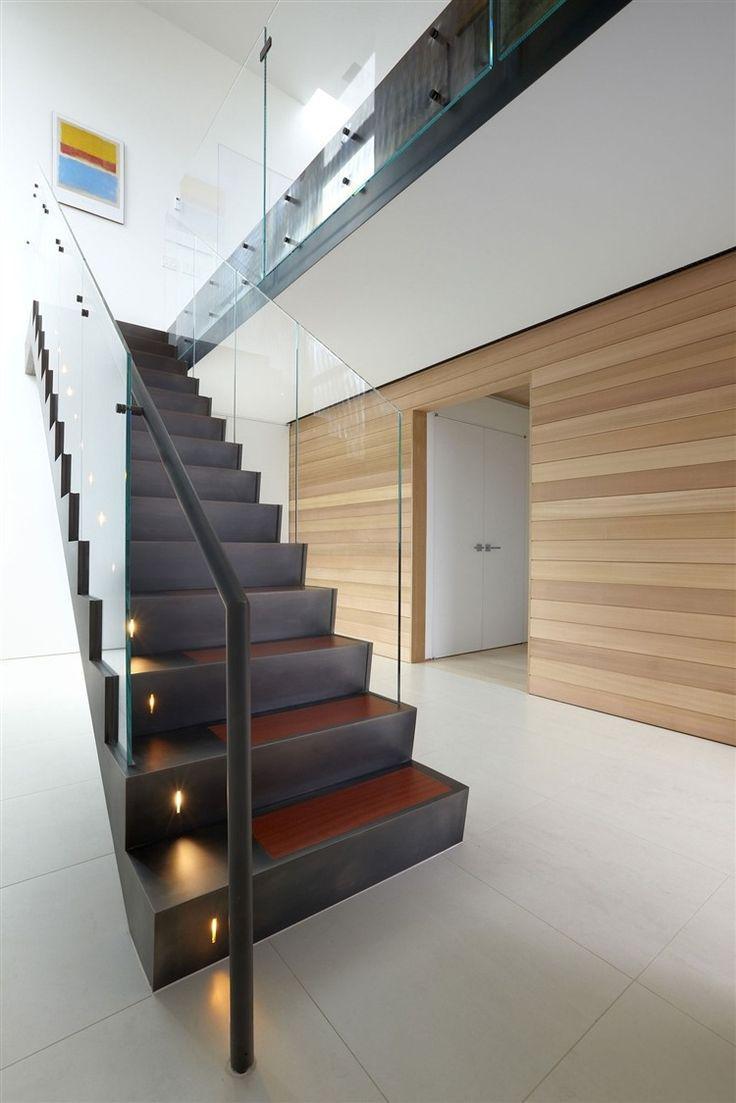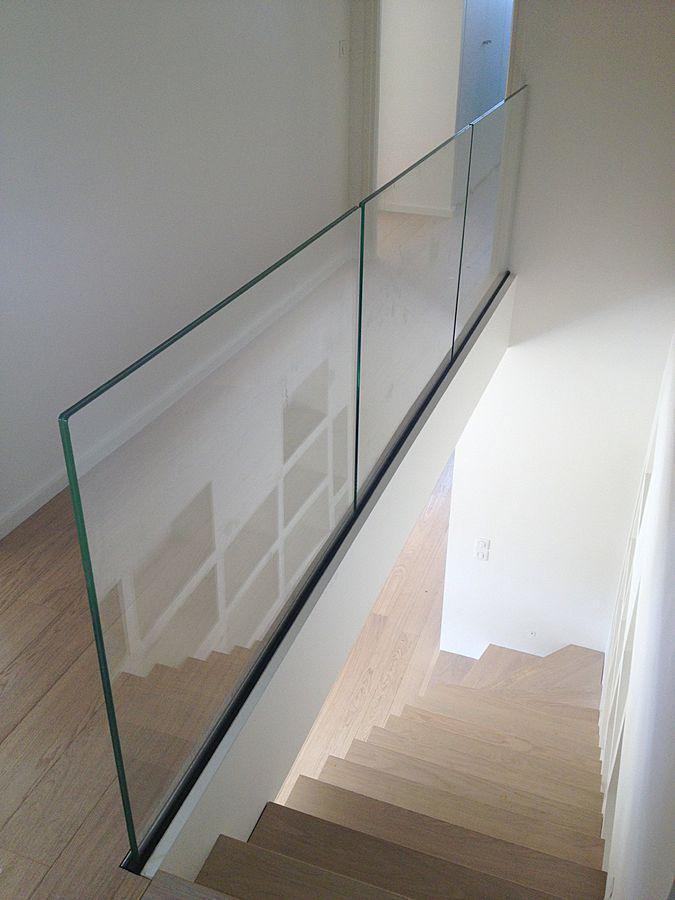The first image is the image on the left, the second image is the image on the right. For the images displayed, is the sentence "An image shows an upward view of an uncurved ascending staircase with glass panels on one side." factually correct? Answer yes or no. Yes. 